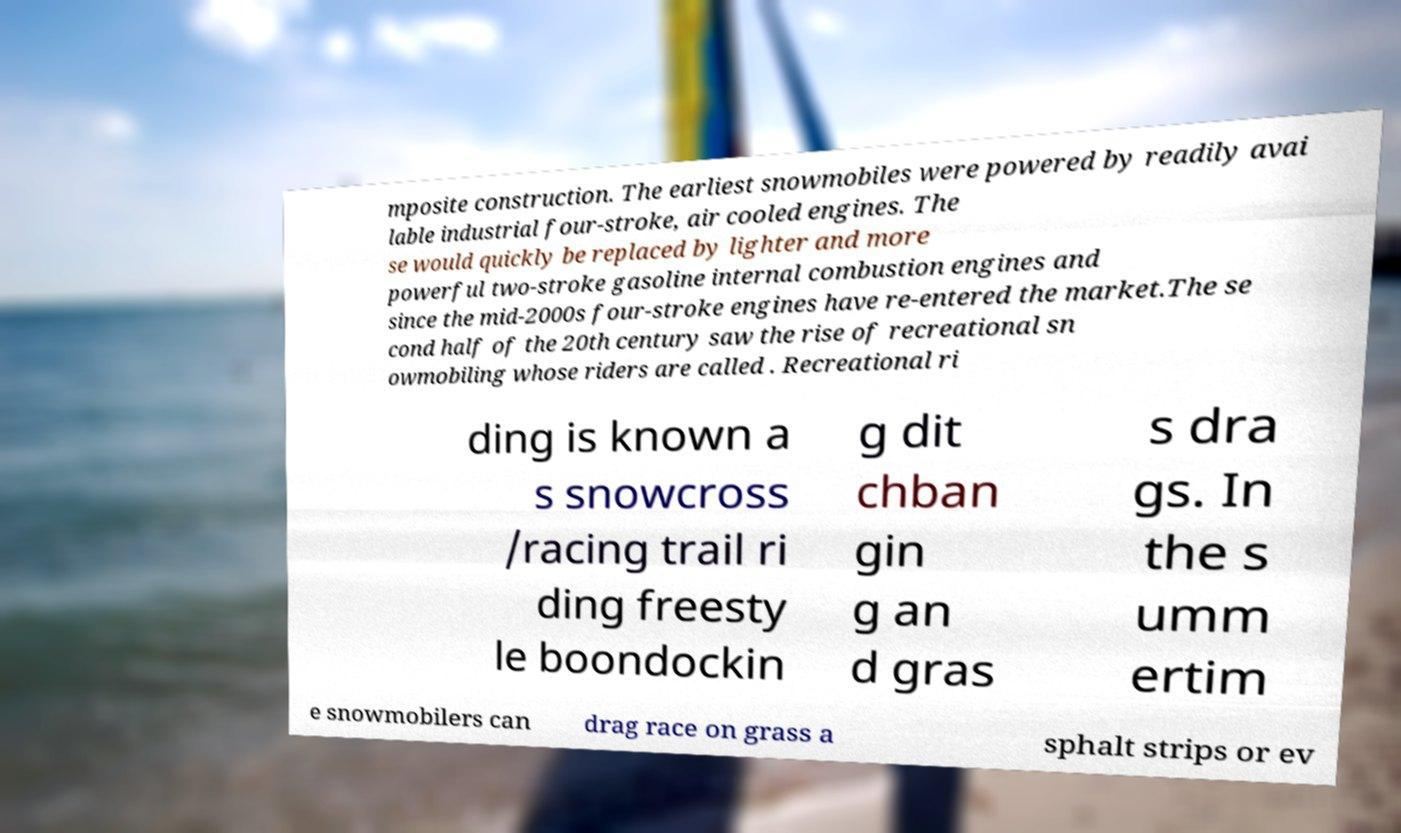I need the written content from this picture converted into text. Can you do that? mposite construction. The earliest snowmobiles were powered by readily avai lable industrial four-stroke, air cooled engines. The se would quickly be replaced by lighter and more powerful two-stroke gasoline internal combustion engines and since the mid-2000s four-stroke engines have re-entered the market.The se cond half of the 20th century saw the rise of recreational sn owmobiling whose riders are called . Recreational ri ding is known a s snowcross /racing trail ri ding freesty le boondockin g dit chban gin g an d gras s dra gs. In the s umm ertim e snowmobilers can drag race on grass a sphalt strips or ev 